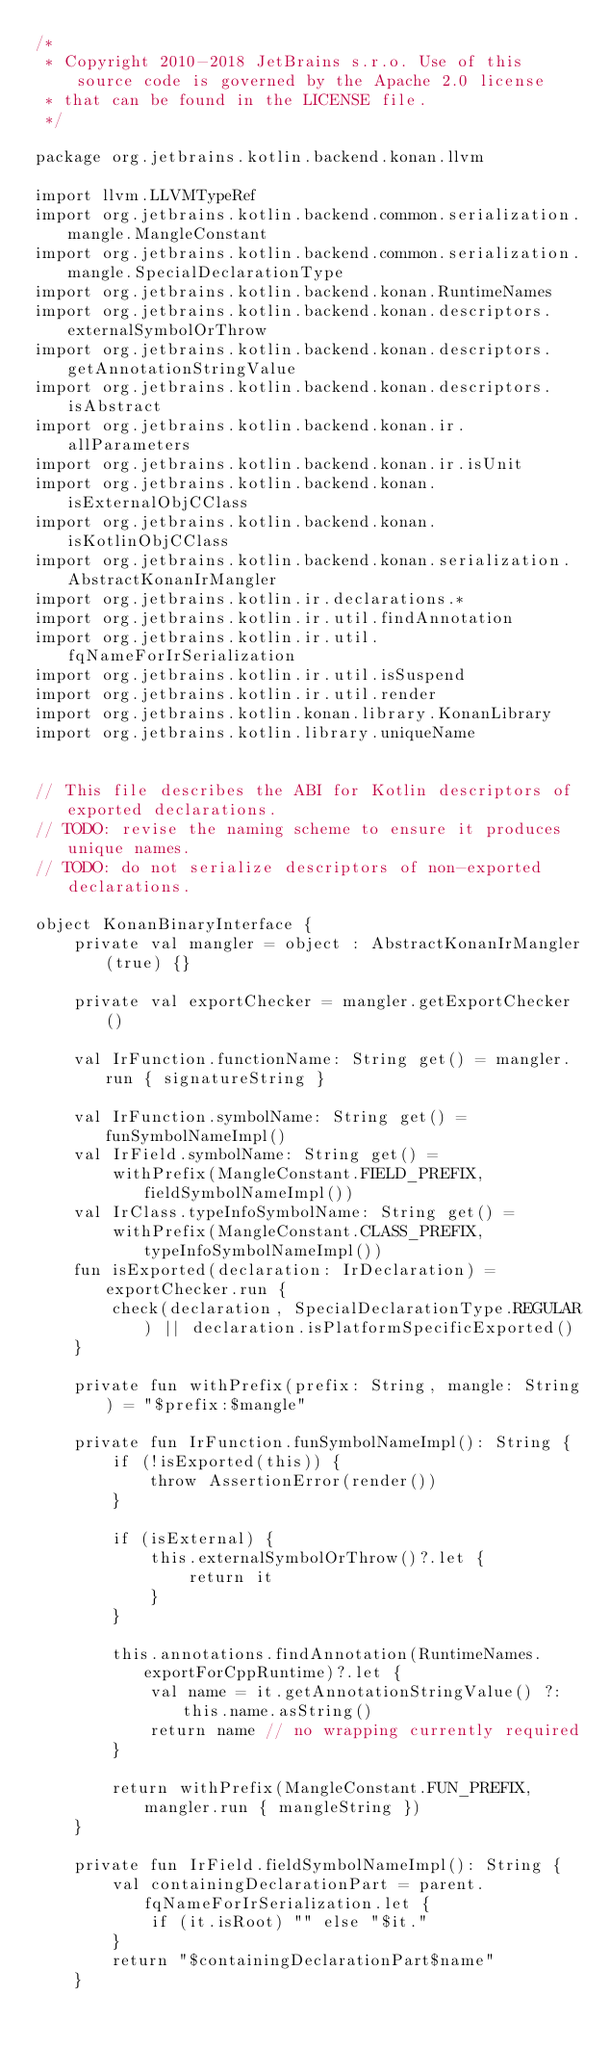Convert code to text. <code><loc_0><loc_0><loc_500><loc_500><_Kotlin_>/*
 * Copyright 2010-2018 JetBrains s.r.o. Use of this source code is governed by the Apache 2.0 license
 * that can be found in the LICENSE file.
 */

package org.jetbrains.kotlin.backend.konan.llvm

import llvm.LLVMTypeRef
import org.jetbrains.kotlin.backend.common.serialization.mangle.MangleConstant
import org.jetbrains.kotlin.backend.common.serialization.mangle.SpecialDeclarationType
import org.jetbrains.kotlin.backend.konan.RuntimeNames
import org.jetbrains.kotlin.backend.konan.descriptors.externalSymbolOrThrow
import org.jetbrains.kotlin.backend.konan.descriptors.getAnnotationStringValue
import org.jetbrains.kotlin.backend.konan.descriptors.isAbstract
import org.jetbrains.kotlin.backend.konan.ir.allParameters
import org.jetbrains.kotlin.backend.konan.ir.isUnit
import org.jetbrains.kotlin.backend.konan.isExternalObjCClass
import org.jetbrains.kotlin.backend.konan.isKotlinObjCClass
import org.jetbrains.kotlin.backend.konan.serialization.AbstractKonanIrMangler
import org.jetbrains.kotlin.ir.declarations.*
import org.jetbrains.kotlin.ir.util.findAnnotation
import org.jetbrains.kotlin.ir.util.fqNameForIrSerialization
import org.jetbrains.kotlin.ir.util.isSuspend
import org.jetbrains.kotlin.ir.util.render
import org.jetbrains.kotlin.konan.library.KonanLibrary
import org.jetbrains.kotlin.library.uniqueName


// This file describes the ABI for Kotlin descriptors of exported declarations.
// TODO: revise the naming scheme to ensure it produces unique names.
// TODO: do not serialize descriptors of non-exported declarations.

object KonanBinaryInterface {
    private val mangler = object : AbstractKonanIrMangler(true) {}

    private val exportChecker = mangler.getExportChecker()

    val IrFunction.functionName: String get() = mangler.run { signatureString }

    val IrFunction.symbolName: String get() = funSymbolNameImpl()
    val IrField.symbolName: String get() =
        withPrefix(MangleConstant.FIELD_PREFIX, fieldSymbolNameImpl())
    val IrClass.typeInfoSymbolName: String get() =
        withPrefix(MangleConstant.CLASS_PREFIX, typeInfoSymbolNameImpl())
    fun isExported(declaration: IrDeclaration) = exportChecker.run {
        check(declaration, SpecialDeclarationType.REGULAR) || declaration.isPlatformSpecificExported()
    }

    private fun withPrefix(prefix: String, mangle: String) = "$prefix:$mangle"

    private fun IrFunction.funSymbolNameImpl(): String {
        if (!isExported(this)) {
            throw AssertionError(render())
        }

        if (isExternal) {
            this.externalSymbolOrThrow()?.let {
                return it
            }
        }

        this.annotations.findAnnotation(RuntimeNames.exportForCppRuntime)?.let {
            val name = it.getAnnotationStringValue() ?: this.name.asString()
            return name // no wrapping currently required
        }

        return withPrefix(MangleConstant.FUN_PREFIX, mangler.run { mangleString })
    }

    private fun IrField.fieldSymbolNameImpl(): String {
        val containingDeclarationPart = parent.fqNameForIrSerialization.let {
            if (it.isRoot) "" else "$it."
        }
        return "$containingDeclarationPart$name"
    }
</code> 